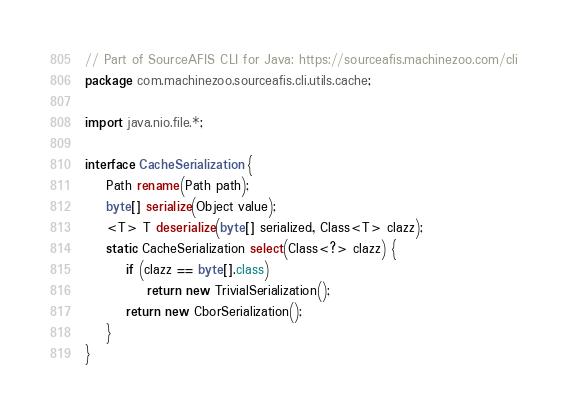Convert code to text. <code><loc_0><loc_0><loc_500><loc_500><_Java_>// Part of SourceAFIS CLI for Java: https://sourceafis.machinezoo.com/cli
package com.machinezoo.sourceafis.cli.utils.cache;

import java.nio.file.*;

interface CacheSerialization {
	Path rename(Path path);
	byte[] serialize(Object value);
	<T> T deserialize(byte[] serialized, Class<T> clazz);
	static CacheSerialization select(Class<?> clazz) {
		if (clazz == byte[].class)
			return new TrivialSerialization();
		return new CborSerialization();
	}
}
</code> 